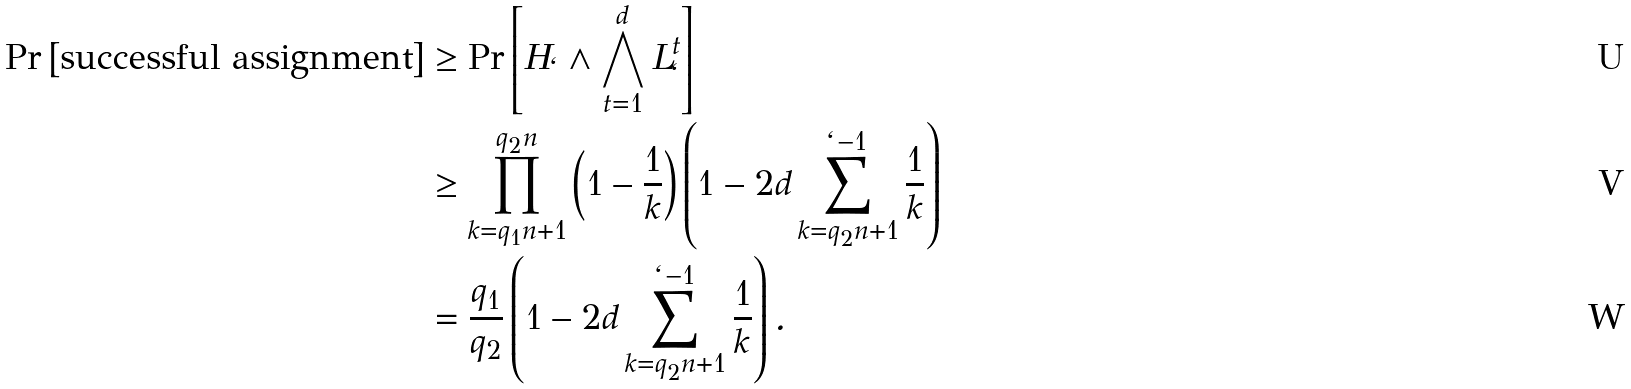Convert formula to latex. <formula><loc_0><loc_0><loc_500><loc_500>\Pr \left [ \text {successful assignment} \right ] & \geq \Pr \left [ H _ { \ell } \wedge \bigwedge _ { t = 1 } ^ { d } L _ { \ell } ^ { t } \right ] \\ & \geq \prod _ { k = q _ { 1 } n + 1 } ^ { q _ { 2 } n } \left ( 1 - \frac { 1 } { k } \right ) \left ( 1 - 2 d \sum _ { k = q _ { 2 } n + 1 } ^ { \ell - 1 } \frac { 1 } { k } \right ) \\ & = \frac { q _ { 1 } } { q _ { 2 } } \left ( 1 - 2 d \sum _ { k = q _ { 2 } n + 1 } ^ { \ell - 1 } \frac { 1 } { k } \right ) .</formula> 